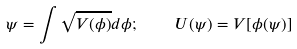Convert formula to latex. <formula><loc_0><loc_0><loc_500><loc_500>\psi = \int \sqrt { V ( \phi ) } d \phi ; \quad U ( \psi ) = V [ \phi ( \psi ) ]</formula> 